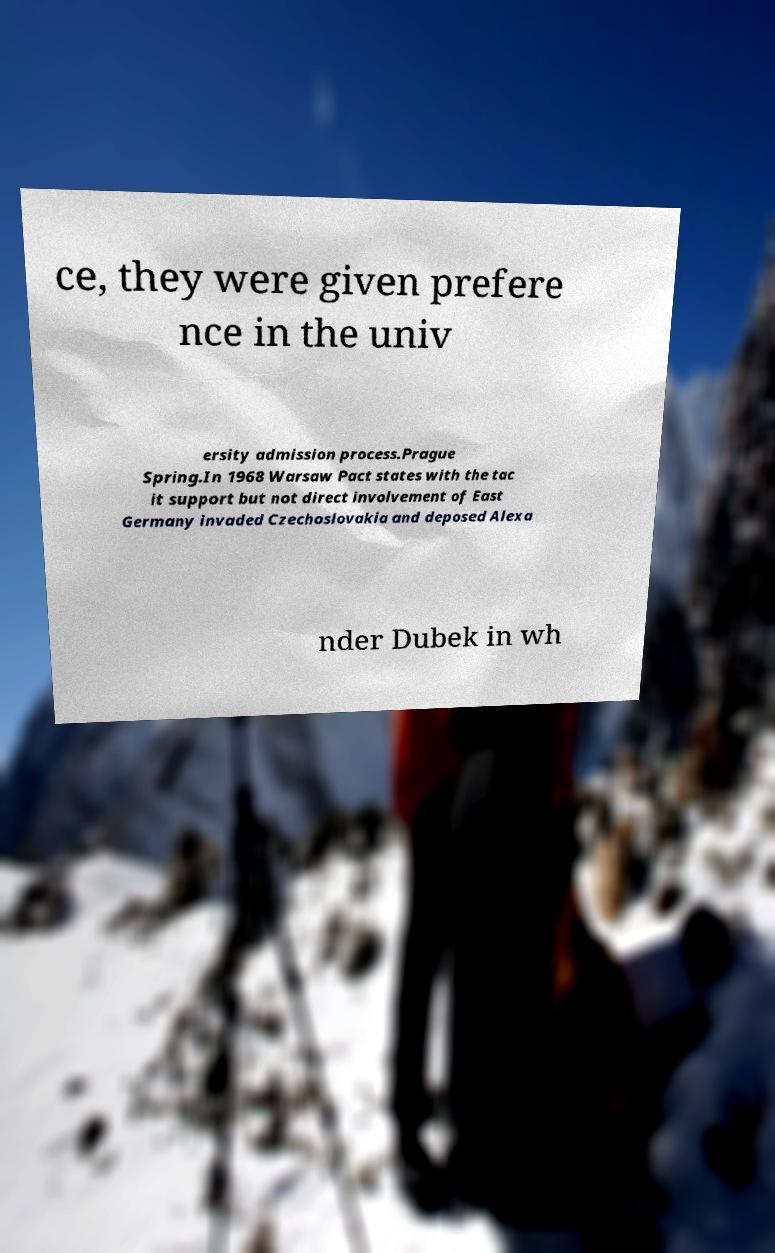I need the written content from this picture converted into text. Can you do that? ce, they were given prefere nce in the univ ersity admission process.Prague Spring.In 1968 Warsaw Pact states with the tac it support but not direct involvement of East Germany invaded Czechoslovakia and deposed Alexa nder Dubek in wh 